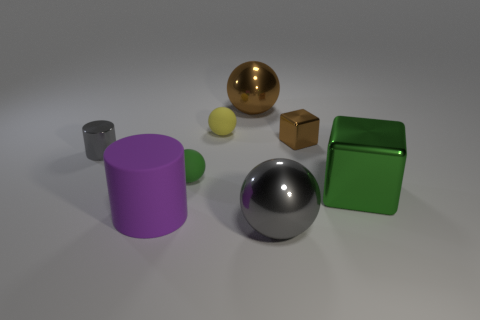Subtract all gray shiny spheres. How many spheres are left? 3 Subtract all yellow spheres. How many spheres are left? 3 Add 1 purple things. How many objects exist? 9 Subtract all cylinders. How many objects are left? 6 Subtract all green spheres. Subtract all cyan blocks. How many spheres are left? 3 Subtract all small green rubber objects. Subtract all big purple objects. How many objects are left? 6 Add 3 small shiny cylinders. How many small shiny cylinders are left? 4 Add 6 big metal things. How many big metal things exist? 9 Subtract 0 yellow blocks. How many objects are left? 8 